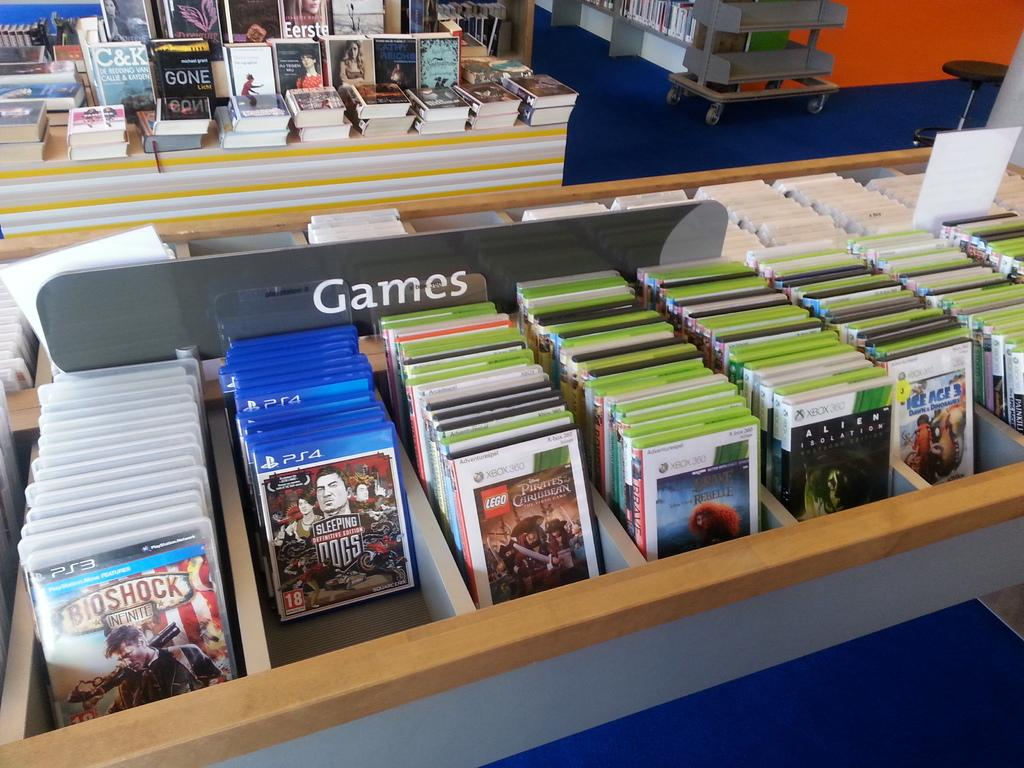<image>
Provide a brief description of the given image. A display table with video games lined up on it. 